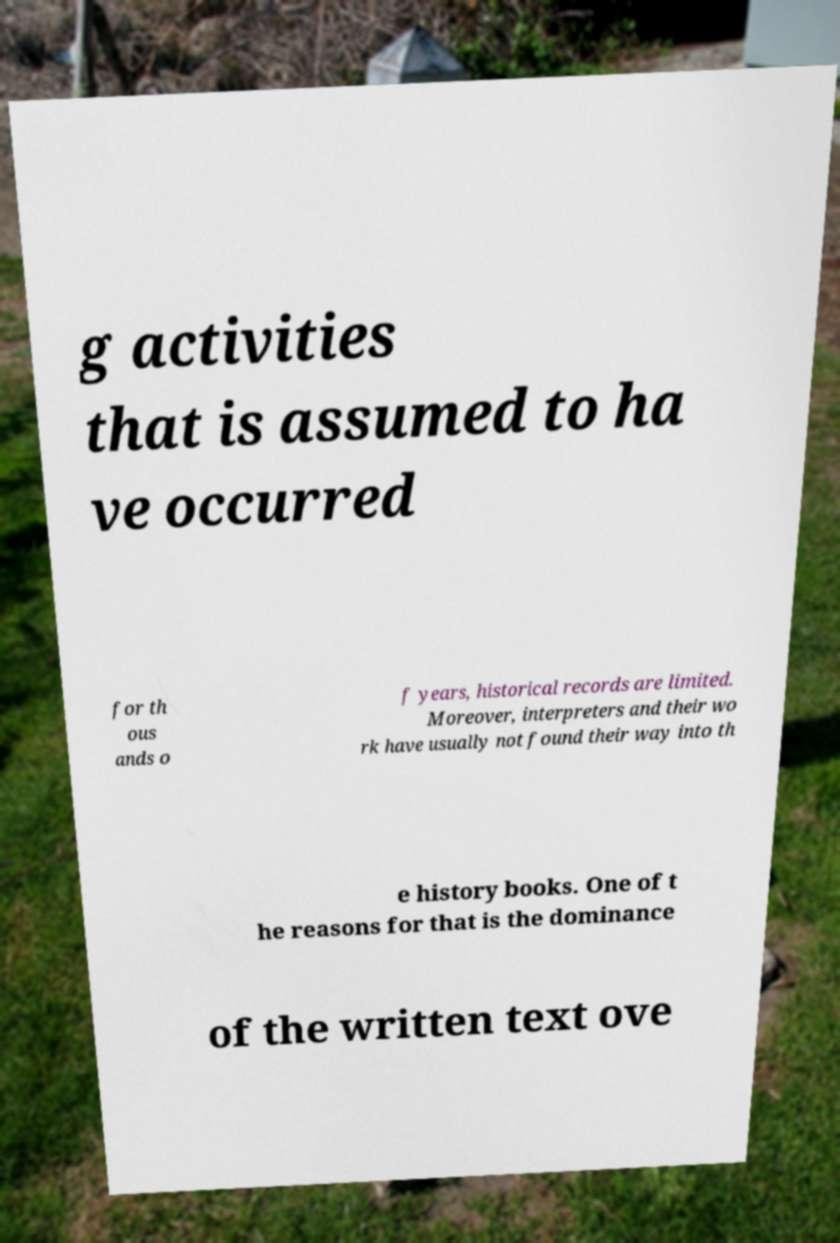Please identify and transcribe the text found in this image. g activities that is assumed to ha ve occurred for th ous ands o f years, historical records are limited. Moreover, interpreters and their wo rk have usually not found their way into th e history books. One of t he reasons for that is the dominance of the written text ove 